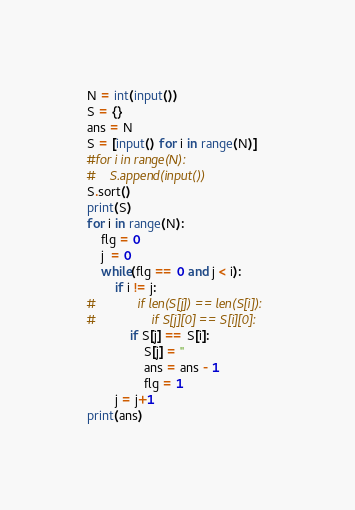Convert code to text. <code><loc_0><loc_0><loc_500><loc_500><_Python_>N = int(input())
S = {}
ans = N
S = [input() for i in range(N)]
#for i in range(N):
#    S.append(input())
S.sort()
print(S)
for i in range(N):
    flg = 0
    j  = 0
    while(flg == 0 and j < i):
        if i != j:
#            if len(S[j]) == len(S[i]):
#                if S[j][0] == S[i][0]:
            if S[j] == S[i]:
                S[j] = ''
                ans = ans - 1
                flg = 1
        j = j+1
print(ans)</code> 